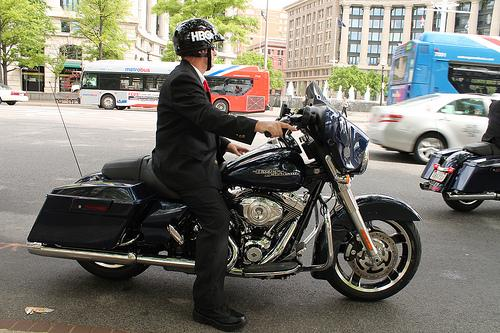What is the condition of the road in the image? The road is tarmaced. What is the man on the motorcycle gripping with his fingers? The man is gripping the handlebar with his fingers curled around it. In a few words, describe the attire of the man on the motorcycle. The man is wearing a black business suit, a red necktie, a black helmet, black dress pants, and black shoes. What is the color of the car in the image? The car is silver. Identify the color of the helmet the man on the motorcycle is wearing. The helmet is black. Give a brief description of someone or something that shares the immediate space or environment of the motorcycle. The motorcycle shares the immediate space or environment with a silver car driving on the street, a white and red bus, and a person in a business suit on another motorcycle. How many motorcycles are there in the image, and what color are they? There are two black motorcycles. Mention one location detail you see in the background of the image. There are trees in the background. What kind of building is shown in the image, and what feature can you see on its exterior? There's a building with windows and a green awning. Is there a bus in the image? If so, what color is it? Yes, there is a bus in the image, and it is blue and red with white detailing. 